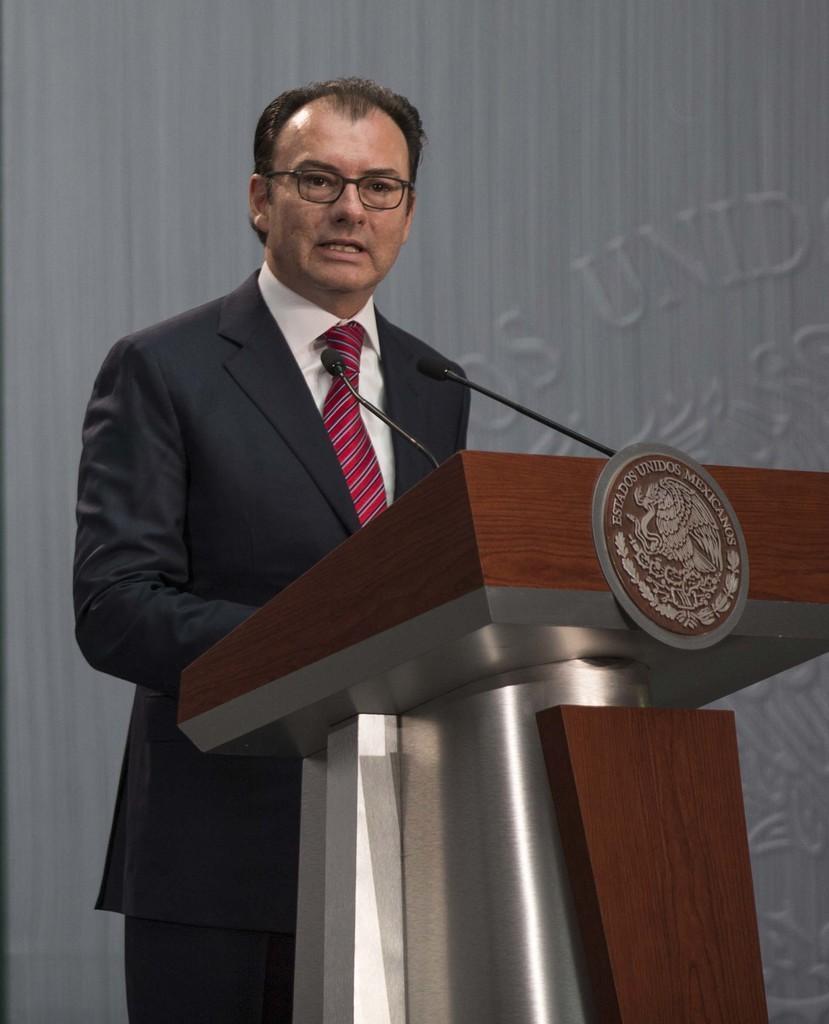How would you summarize this image in a sentence or two? In this image, we can see a man standing and there is a podium, we can see two microphones. 